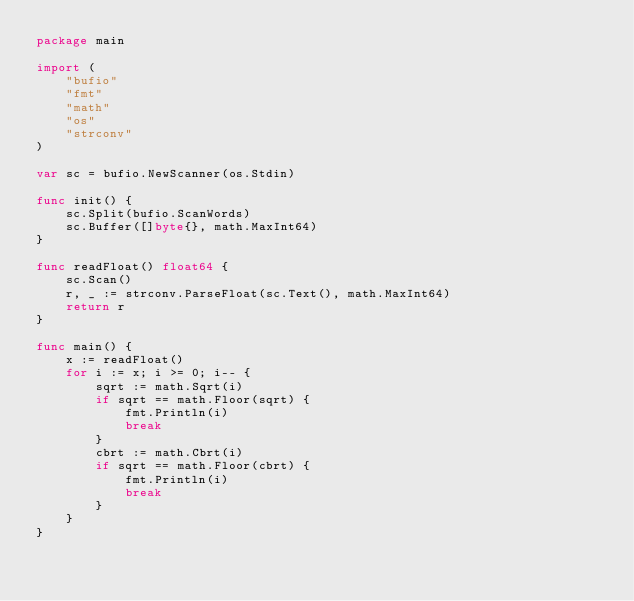<code> <loc_0><loc_0><loc_500><loc_500><_Go_>package main

import (
	"bufio"
	"fmt"
	"math"
	"os"
	"strconv"
)

var sc = bufio.NewScanner(os.Stdin)

func init() {
	sc.Split(bufio.ScanWords)
	sc.Buffer([]byte{}, math.MaxInt64)
}

func readFloat() float64 {
	sc.Scan()
	r, _ := strconv.ParseFloat(sc.Text(), math.MaxInt64)
	return r
}

func main() {
	x := readFloat()
	for i := x; i >= 0; i-- {
		sqrt := math.Sqrt(i)
		if sqrt == math.Floor(sqrt) {
			fmt.Println(i)
			break
		}
		cbrt := math.Cbrt(i)
		if sqrt == math.Floor(cbrt) {
			fmt.Println(i)
			break
		}
	}
}
</code> 